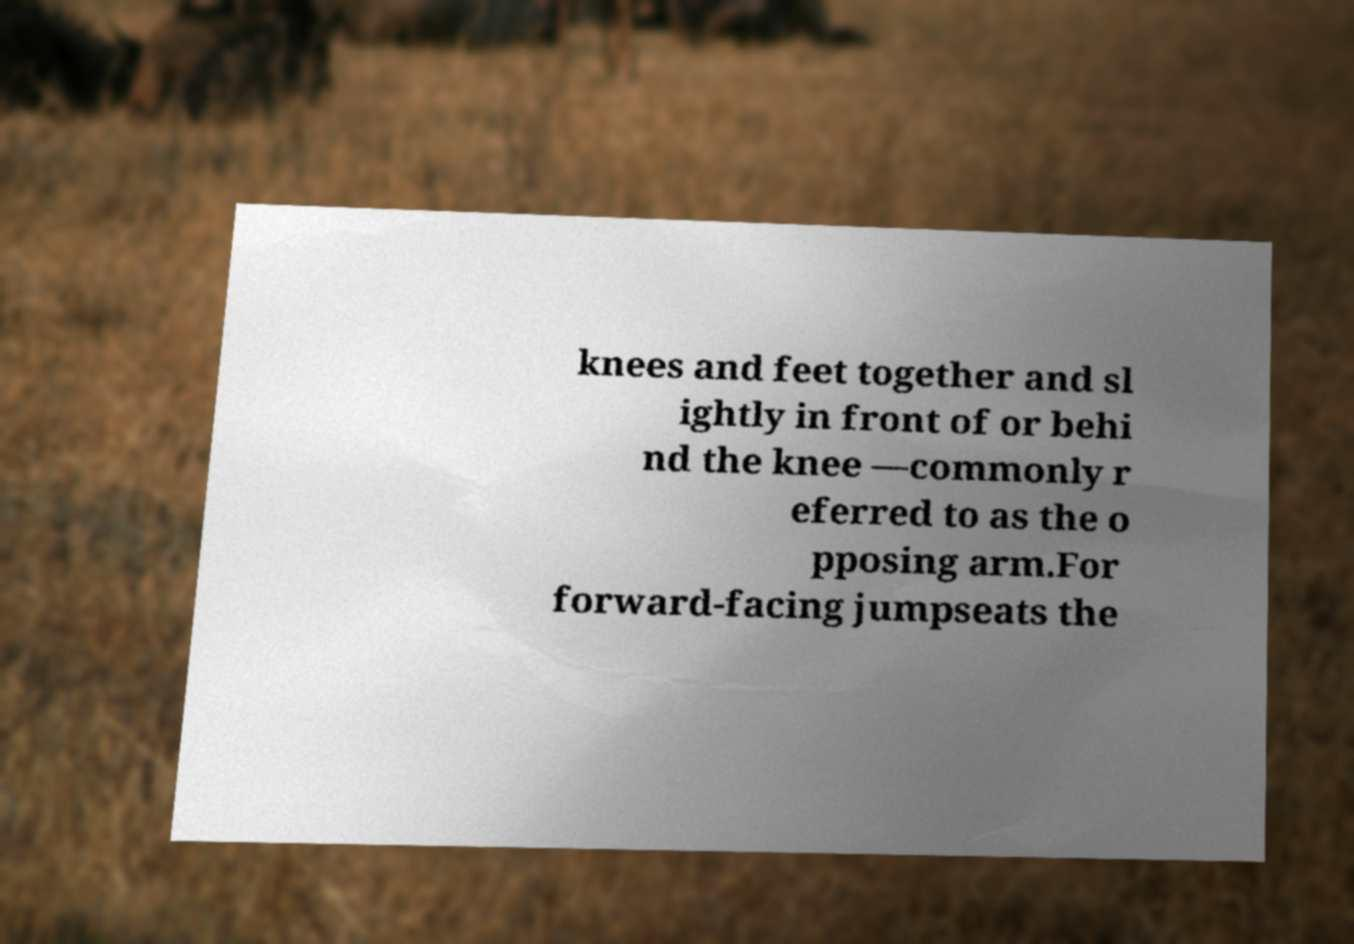I need the written content from this picture converted into text. Can you do that? knees and feet together and sl ightly in front of or behi nd the knee —commonly r eferred to as the o pposing arm.For forward-facing jumpseats the 